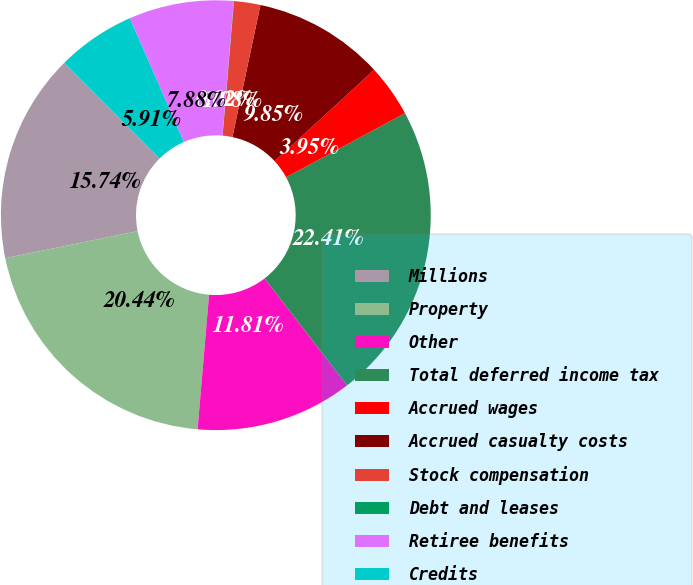Convert chart to OTSL. <chart><loc_0><loc_0><loc_500><loc_500><pie_chart><fcel>Millions<fcel>Property<fcel>Other<fcel>Total deferred income tax<fcel>Accrued wages<fcel>Accrued casualty costs<fcel>Stock compensation<fcel>Debt and leases<fcel>Retiree benefits<fcel>Credits<nl><fcel>15.74%<fcel>20.44%<fcel>11.81%<fcel>22.41%<fcel>3.95%<fcel>9.85%<fcel>1.98%<fcel>0.02%<fcel>7.88%<fcel>5.91%<nl></chart> 